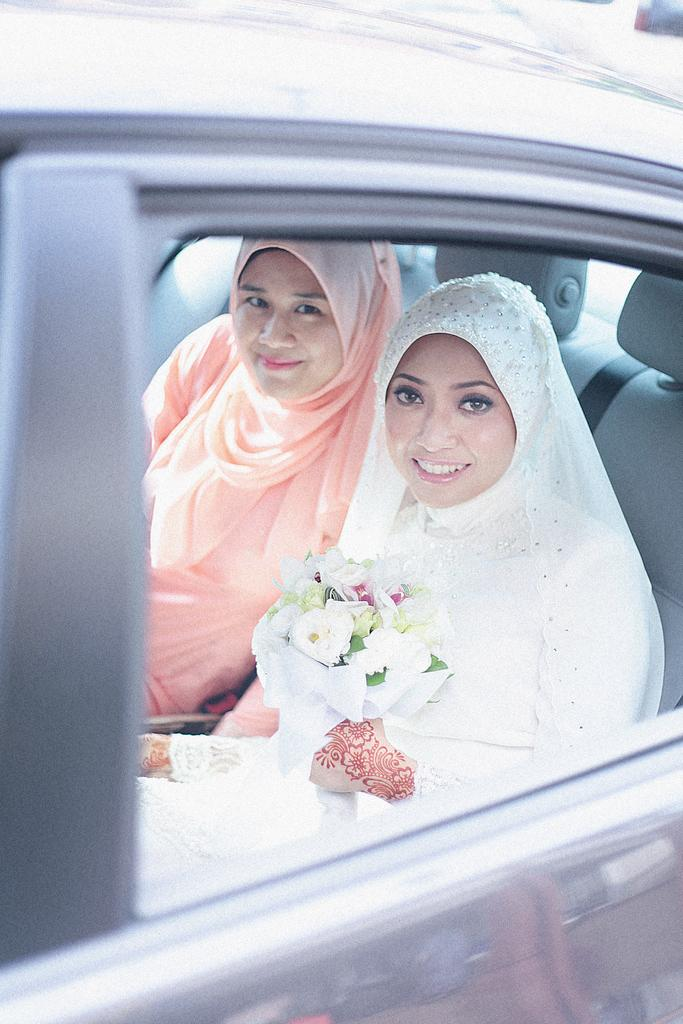How many people are in the image? There are two women in the image. What are the women doing in the image? The women are smiling in the image. Where are the women sitting in the image? The women are sitting on a car. What is one of the women holding in the image? One of the women is holding a flower bouquet. What type of bat is hanging from the collar of one of the women in the image? There is no bat or collar present in the image. What type of business are the women discussing in the image? The image does not show any discussion about a business; it only shows the two women sitting on a car and smiling. 